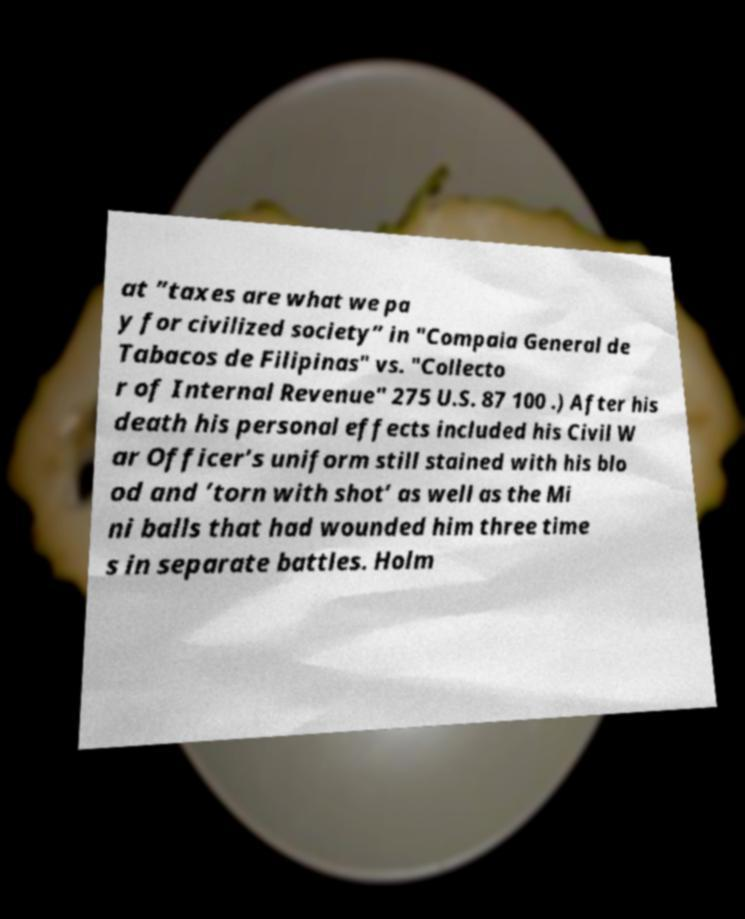There's text embedded in this image that I need extracted. Can you transcribe it verbatim? at ”taxes are what we pa y for civilized society” in "Compaia General de Tabacos de Filipinas" vs. "Collecto r of Internal Revenue" 275 U.S. 87 100 .) After his death his personal effects included his Civil W ar Officer’s uniform still stained with his blo od and ’torn with shot’ as well as the Mi ni balls that had wounded him three time s in separate battles. Holm 